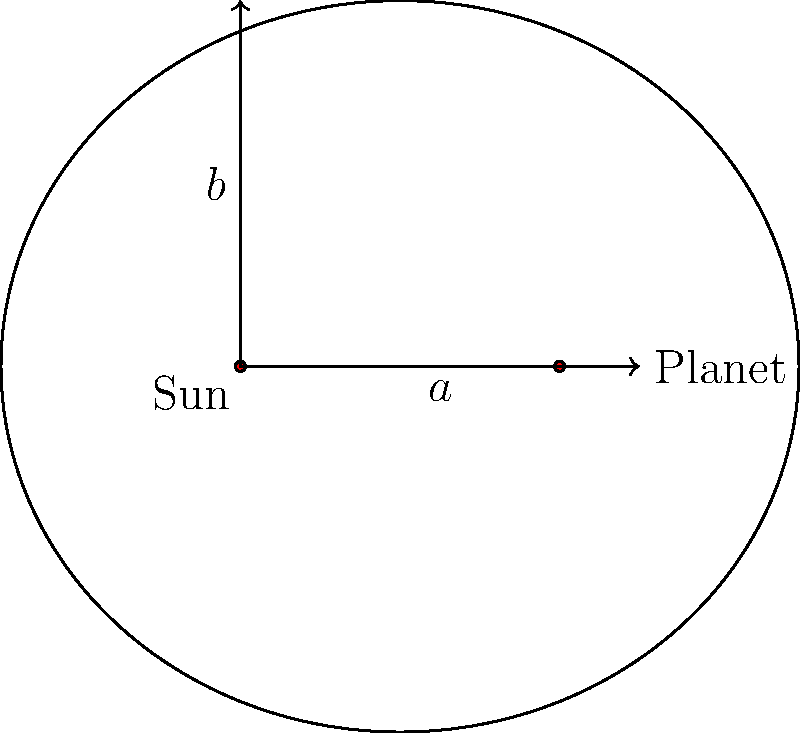In the diagram above, which represents the orbit of a planet around the sun, what is the relationship between the semi-major axis $a$, the semi-minor axis $b$, and the distance $c$ from the center to either focus in an elliptical orbit? Express your answer in terms of $a$, $b$, and $c$. To understand the relationship between $a$, $b$, and $c$ in an elliptical orbit, let's follow these steps:

1. In an ellipse, the semi-major axis $a$ is the longest radius from the center to the edge of the ellipse.

2. The semi-minor axis $b$ is the shortest radius from the center to the edge of the ellipse.

3. The distance $c$ from the center to either focus is related to the eccentricity of the ellipse.

4. In an ellipse, there's a fundamental relationship between these three quantities:

   $$a^2 = b^2 + c^2$$

5. This relationship is derived from the Pythagorean theorem applied to the right triangle formed by $a$, $b$, and $c$.

6. We can rearrange this equation to express it in the form asked in the question:

   $$c^2 = a^2 - b^2$$

This equation shows how the three key parameters of an elliptical orbit are related. It's crucial for understanding planetary orbits and Kepler's laws of planetary motion.
Answer: $c^2 = a^2 - b^2$ 